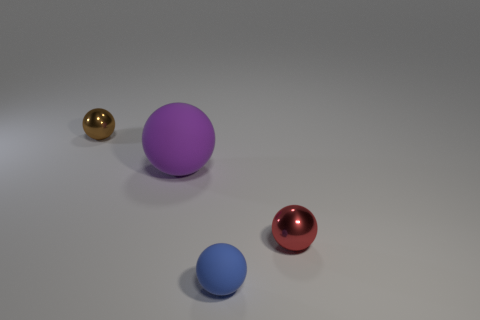Are there the same number of big purple rubber balls that are in front of the purple rubber ball and big purple matte objects on the right side of the tiny red sphere?
Give a very brief answer. Yes. There is a object that is both on the right side of the brown thing and to the left of the small blue rubber object; what material is it made of?
Keep it short and to the point. Rubber. There is a purple sphere; is it the same size as the shiny sphere in front of the brown shiny sphere?
Your answer should be very brief. No. How many other things are the same color as the large sphere?
Keep it short and to the point. 0. Is the number of big purple matte spheres in front of the blue object greater than the number of big yellow metallic blocks?
Give a very brief answer. No. There is a metallic ball on the left side of the small shiny object in front of the tiny sphere behind the red object; what color is it?
Offer a terse response. Brown. Does the tiny brown object have the same material as the large purple thing?
Provide a short and direct response. No. Is there a brown ball that has the same size as the blue matte sphere?
Provide a short and direct response. Yes. There is a blue thing that is the same size as the red metal object; what material is it?
Provide a short and direct response. Rubber. Is there a tiny brown object of the same shape as the blue matte object?
Give a very brief answer. Yes. 